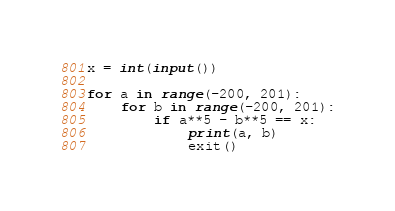<code> <loc_0><loc_0><loc_500><loc_500><_Python_>x = int(input())

for a in range(-200, 201):
    for b in range(-200, 201):
        if a**5 - b**5 == x:
            print(a, b)
            exit()</code> 